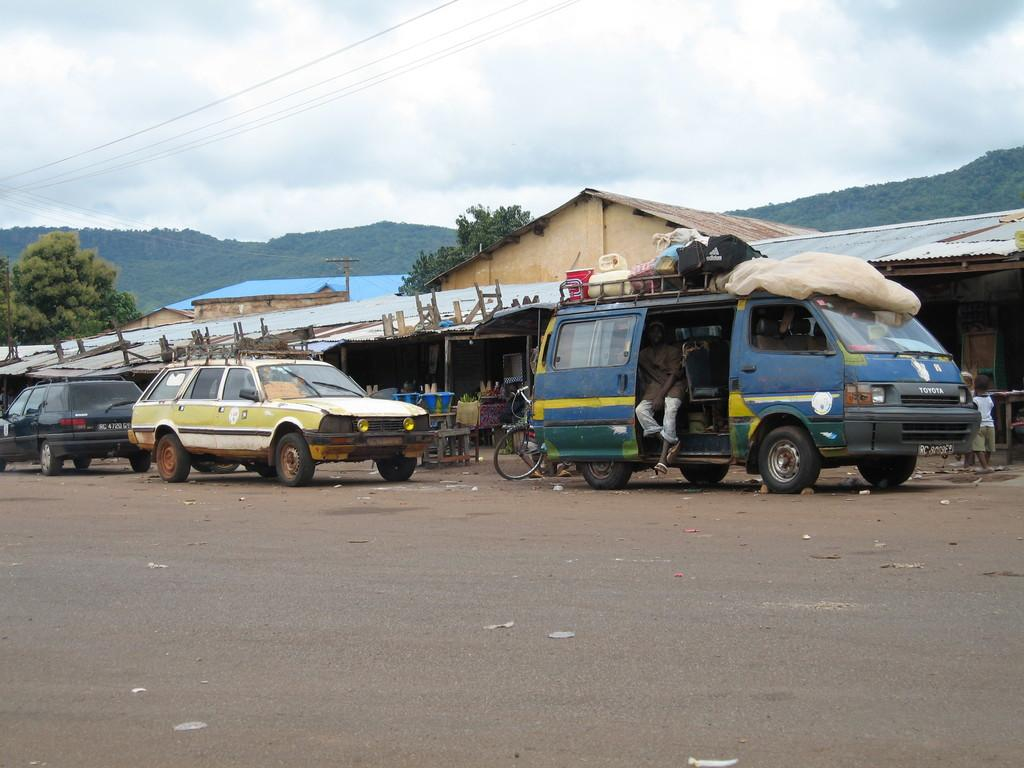What can be seen on the road in the image? There are vehicles on the road in the image. What type of vegetation is present in the image? There are trees in the image. What type of structures can be seen in the image? There are sheds in the image. What else is visible in the image besides the vehicles, trees, and sheds? Wires are visible in the image. What is visible in the background of the image? The sky with clouds is visible in the background of the image. What type of debt is being discussed in the image? There is no mention of debt in the image; it features vehicles, trees, sheds, wires, and a sky with clouds. What rule is being enforced in the image? There is no rule being enforced in the image; it is a scene with vehicles, trees, sheds, wires, and a sky with clouds. 